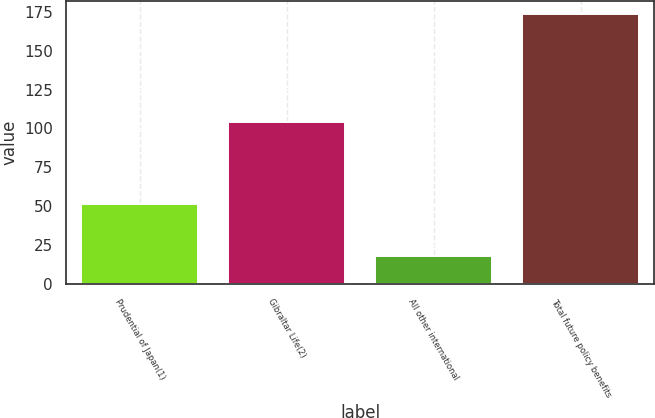Convert chart to OTSL. <chart><loc_0><loc_0><loc_500><loc_500><bar_chart><fcel>Prudential of Japan(1)<fcel>Gibraltar Life(2)<fcel>All other international<fcel>Total future policy benefits<nl><fcel>51.6<fcel>104.3<fcel>17.7<fcel>173.6<nl></chart> 